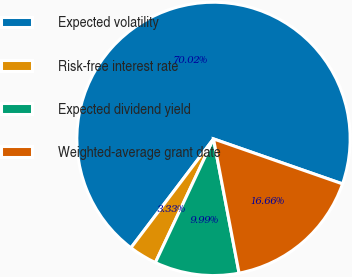Convert chart. <chart><loc_0><loc_0><loc_500><loc_500><pie_chart><fcel>Expected volatility<fcel>Risk-free interest rate<fcel>Expected dividend yield<fcel>Weighted-average grant date<nl><fcel>70.02%<fcel>3.33%<fcel>9.99%<fcel>16.66%<nl></chart> 